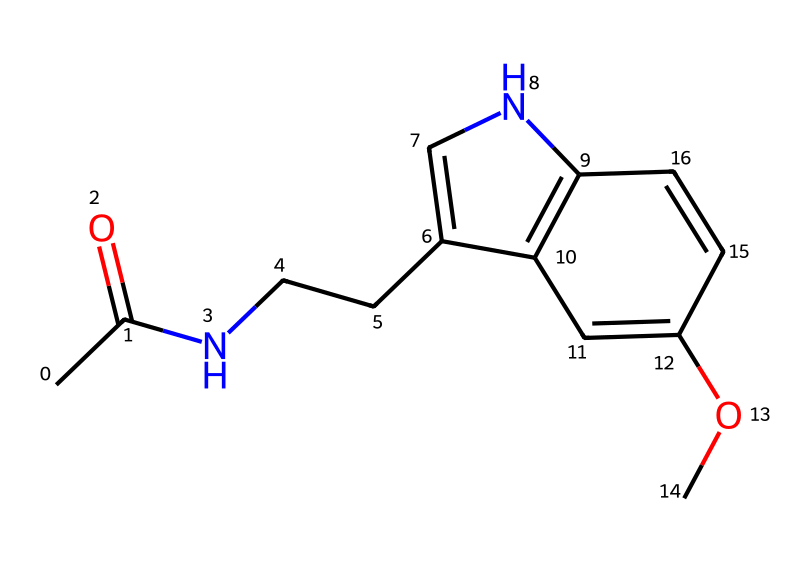What is the main functional group in melatonin? The structure shows an amide group (due to the presence of a carbonyl (C=O) bonded to a nitrogen atom (N)). This amide is critical to the chemical properties of melatonin.
Answer: amide How many rings are present in the structure of melatonin? Upon examining the SMILES representation, there are two fused rings indicated by the numerical labels (1 and 2). Each label denotes a ring junction, confirming two cyclic components in the structure.
Answer: two What element is represented by the symbol 'N' in the SMILES? The 'N' in the SMILES stands for nitrogen, which is a crucial component for the hormone functionality and is part of the amide group present.
Answer: nitrogen How many double bonds are found in the melatonin structure? By analyzing the structure, we can count four double bonds: two in the aromatic ring and two in the aliphatic portion of the molecule (noted from the placement of '=' signs in the SMILES).
Answer: four What type of chemical is melatonin classified as? Melatonin is classified as a hormone, particularly due to its role in regulating sleep patterns in the body, as indicated by its biochemical properties which are aligned with hormonal functions.
Answer: hormone Which part of the melatonin structure allows it to cross the blood-brain barrier? The presence of a small, lipophilic structure and specific aromatic rings enhances melatonin's ability to cross the blood-brain barrier, representing its designed function as a neurohormone.
Answer: aromatic rings 